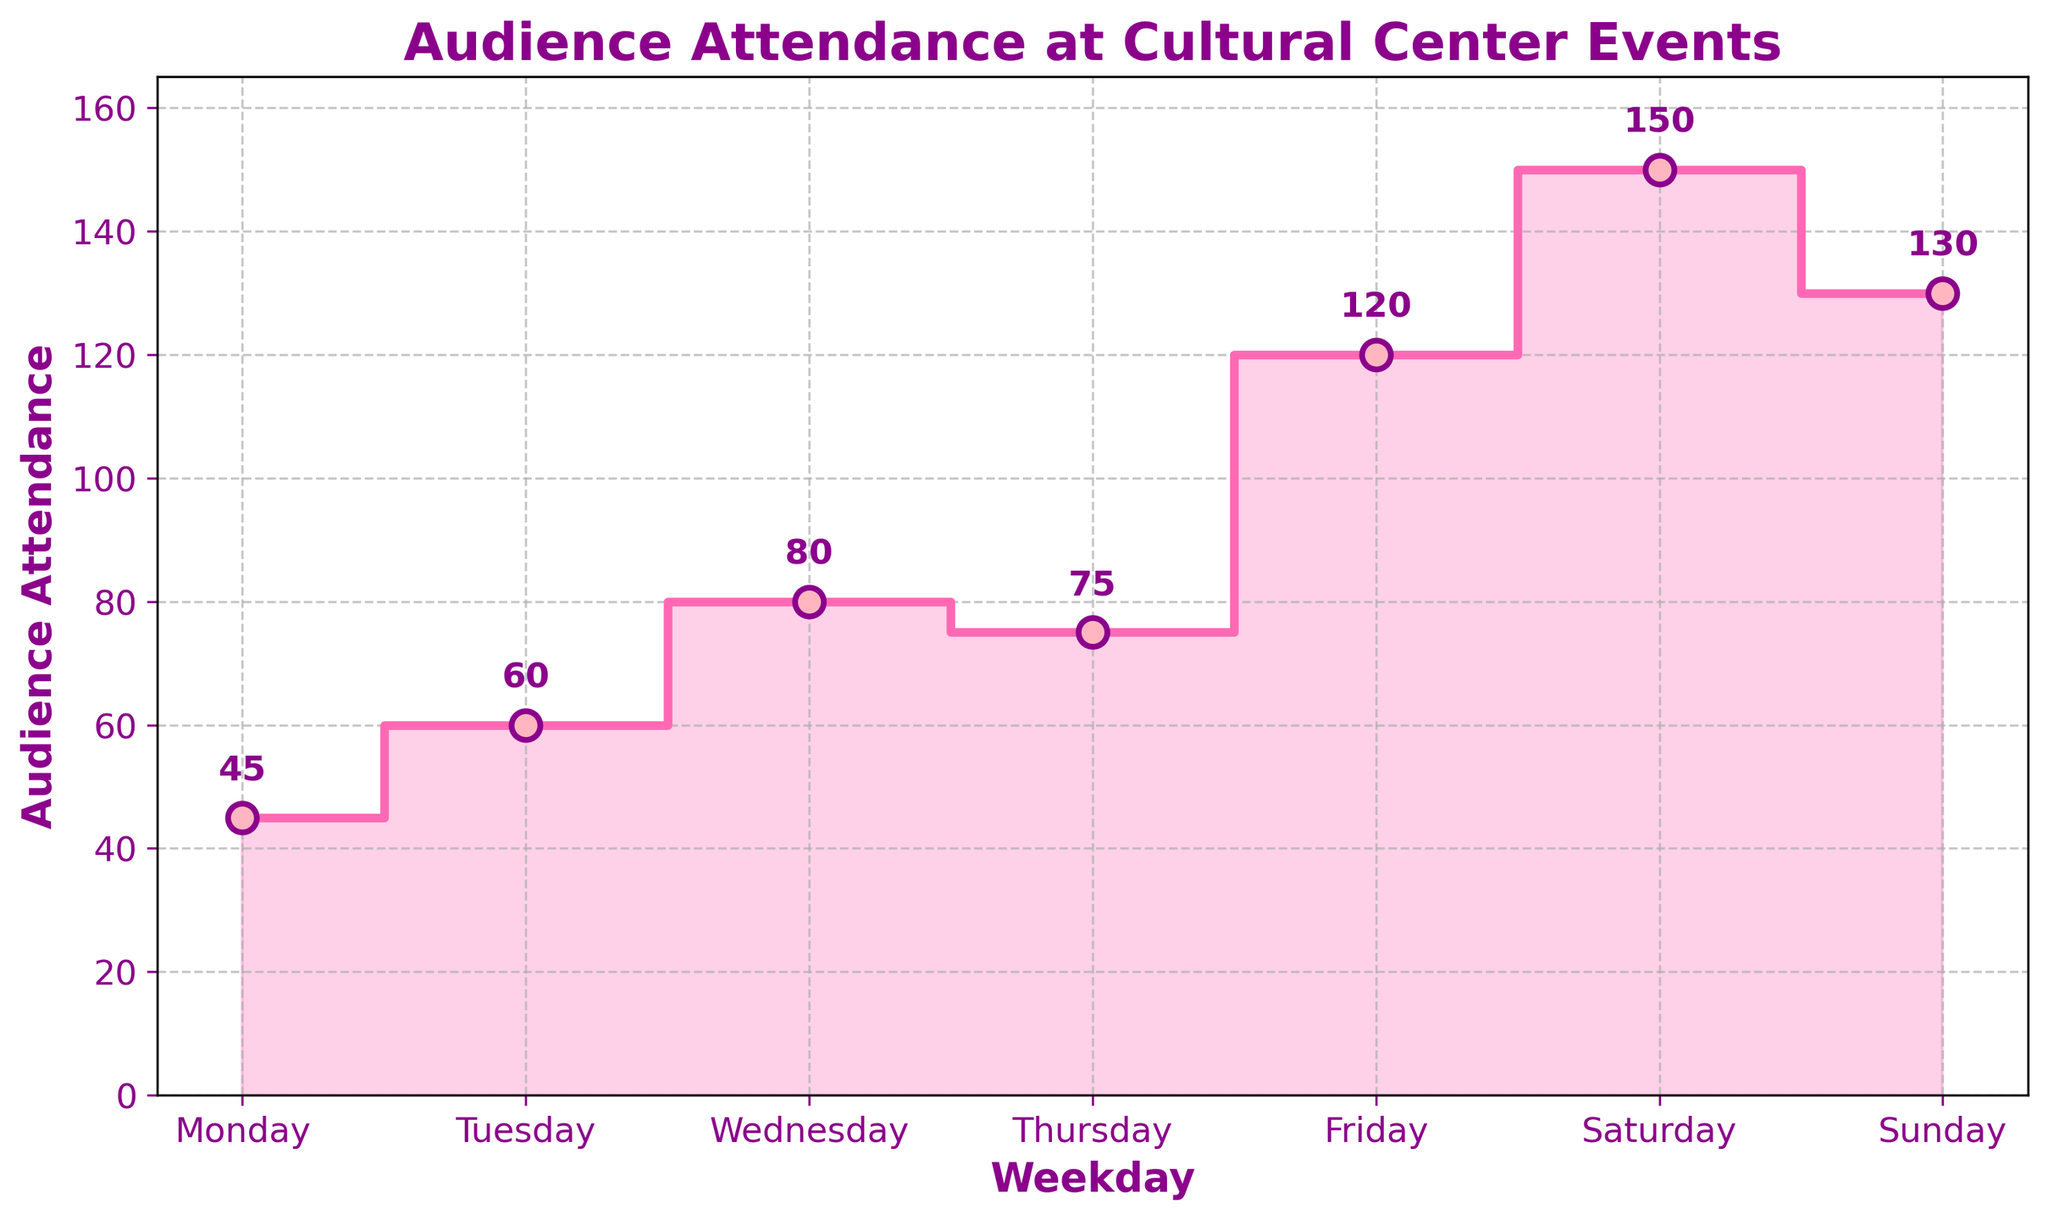What is the title of the plot? The title of the plot is usually found at the top center of the figure. From the description, the title stated is "Audience Attendance at Cultural Center Events".
Answer: Audience Attendance at Cultural Center Events On which day is the audience attendance the highest? To find the highest audience attendance, look for the weekday with the maximum value on the y-axis. The highest value is 150, which corresponds to Saturday.
Answer: Saturday What is the difference in audience attendance between Friday and Wednesday? Subtract the attendance on Wednesday (80) from the attendance on Friday (120).
Answer: 40 Which days have audience attendance greater than 100? Identify all weekdays where the value on the y-axis is greater than 100. These days are Friday (120), Saturday (150), and Sunday (130).
Answer: Friday, Saturday, Sunday How does the audience attendance change from Monday to Sunday? Track the audience attendance sequentially from Monday (45), Tuesday (60), Wednesday (80), Thursday (75), Friday (120), Saturday (150), to Sunday (130). The attendance generally increases, with a small drop on Thursday, and then a peak on Saturday before a slight drop on Sunday.
Answer: Generally increases; peaks on Saturday What is the average audience attendance for the week? Sum all attendance values (45 + 60 + 80 + 75 + 120 + 150 + 130) and divide by the number of days (7). The sum is 660, so the average is 660/7.
Answer: 94.29 Which two consecutive days have the highest increase in audience attendance? Calculate the increase in audience attendance between each consecutive pair of days and compare. The differences are: 
- Monday to Tuesday: 60 - 45 = 15
- Tuesday to Wednesday: 80 - 60 = 20
- Wednesday to Thursday: 75 - 80 = -5
- Thursday to Friday: 120 - 75 = 45
- Friday to Saturday: 150 - 120 = 30
- Saturday to Sunday: 130 - 150 = -20
The highest increase is from Thursday (75) to Friday (120).
Answer: Thursday to Friday What is the median audience attendance for the week? Order the attendance values from smallest to largest: 45, 60, 75, 80, 120, 130, 150. The median is the middle value, which is the fourth value here (80).
Answer: 80 Is there any day with a significant drop in attendance compared to the previous day? Examine the differences between the attendance values of consecutive days. The only days with a drop are Wednesday to Thursday (5 less) and Saturday to Sunday (20 less). The significant drop occurs from Saturday (150) to Sunday (130).
Answer: Yes, from Saturday to Sunday How many days have an attendance of more than double that of Monday? Double of Monday's attendance (45) is 90. Days with attendance above 90 are Wednesday (80 does not count), Friday (120), Saturday (150), and Sunday (130).
Answer: Three days (Friday, Saturday, Sunday) 